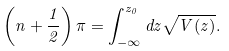<formula> <loc_0><loc_0><loc_500><loc_500>\left ( n + \frac { 1 } { 2 } \right ) \pi = \int _ { - \infty } ^ { z _ { 0 } } d z \sqrt { V ( z ) } .</formula> 